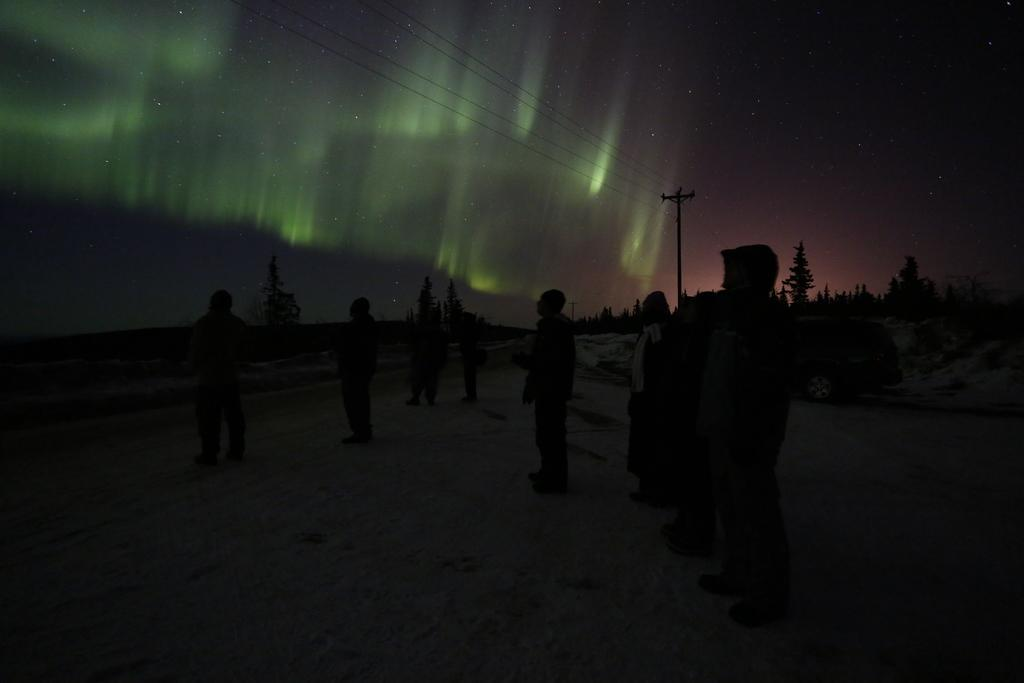What can be seen in the image involving people? There are persons standing in the image. What type of natural elements are present in the image? There are trees and plants in the image. What man-made structures can be seen in the image? There are wires and an electric pole in the image. What is visible in the sky in the image? Stars are visible in the sky in the image. Can you see a snake slithering through the plants in the image? There is no snake present in the image; only trees, plants, wires, an electric pole, and stars are visible. Are there any visible ear structures on the persons standing in the image? The image does not show any visible ear structures on the persons standing in the image. 